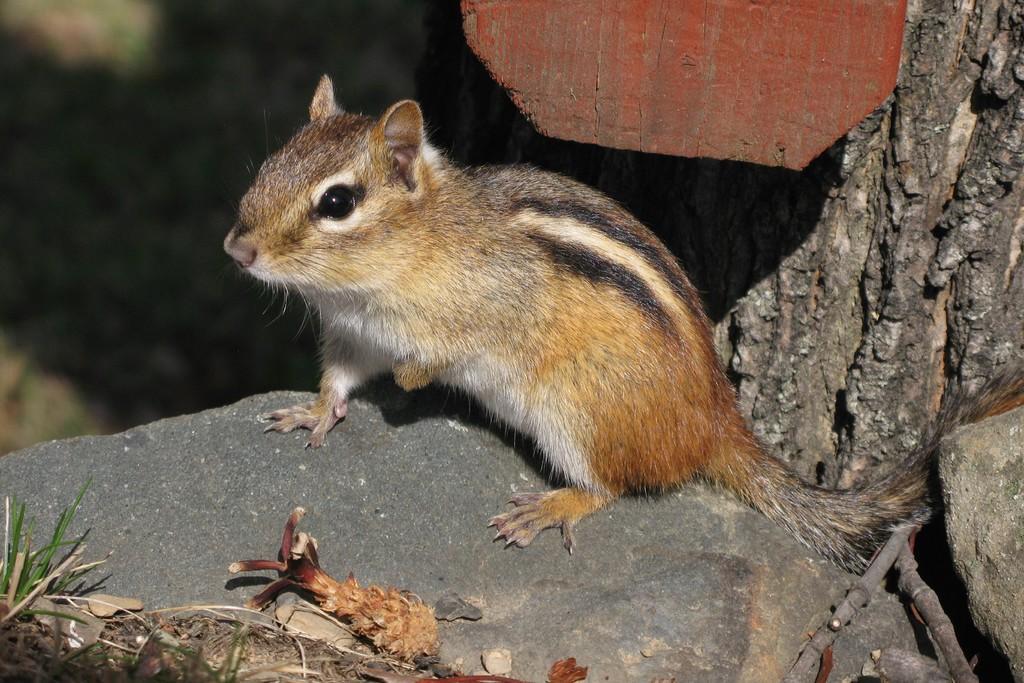Could you give a brief overview of what you see in this image? In this image there is a squirrel in the front standing on stone. On the right side there is a tree trunk and the background is blurry. 